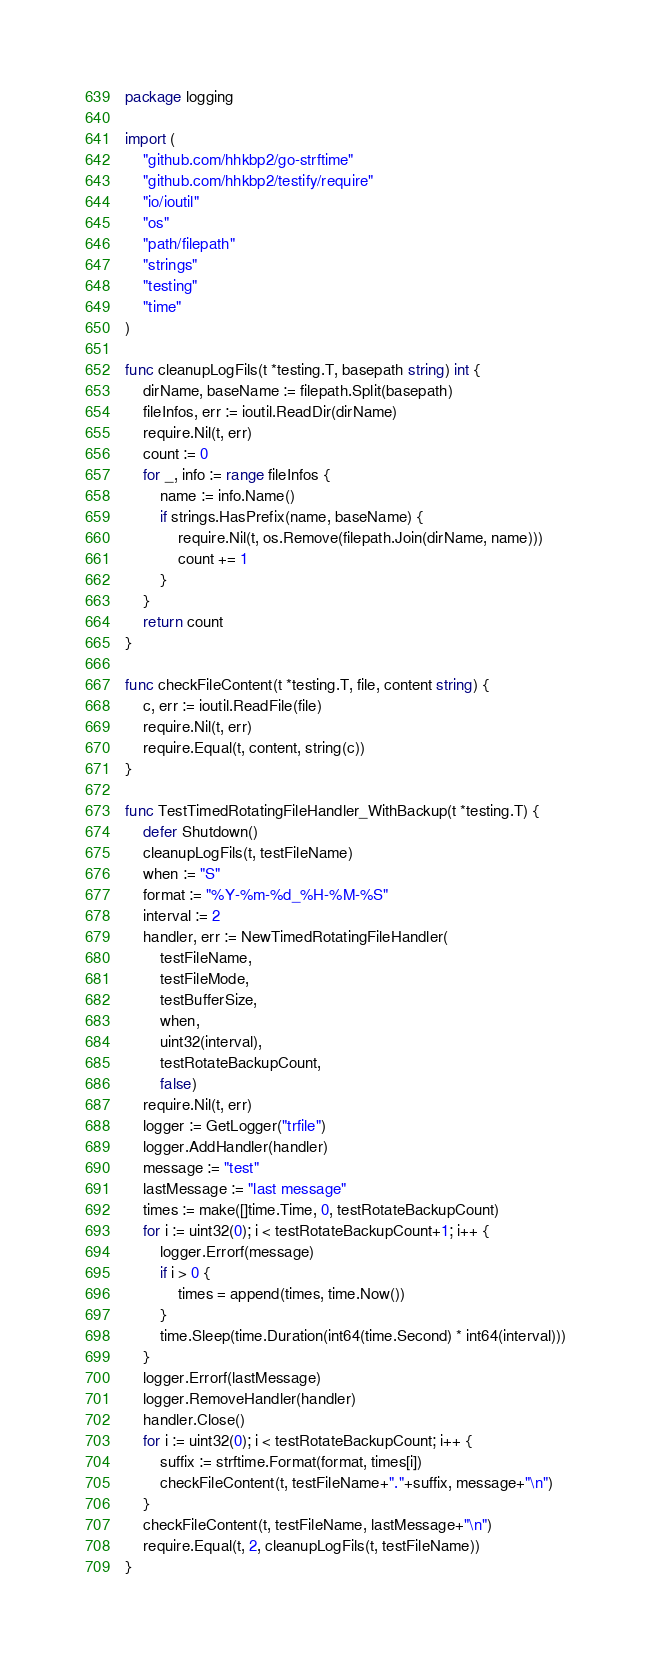<code> <loc_0><loc_0><loc_500><loc_500><_Go_>package logging

import (
	"github.com/hhkbp2/go-strftime"
	"github.com/hhkbp2/testify/require"
	"io/ioutil"
	"os"
	"path/filepath"
	"strings"
	"testing"
	"time"
)

func cleanupLogFils(t *testing.T, basepath string) int {
	dirName, baseName := filepath.Split(basepath)
	fileInfos, err := ioutil.ReadDir(dirName)
	require.Nil(t, err)
	count := 0
	for _, info := range fileInfos {
		name := info.Name()
		if strings.HasPrefix(name, baseName) {
			require.Nil(t, os.Remove(filepath.Join(dirName, name)))
			count += 1
		}
	}
	return count
}

func checkFileContent(t *testing.T, file, content string) {
	c, err := ioutil.ReadFile(file)
	require.Nil(t, err)
	require.Equal(t, content, string(c))
}

func TestTimedRotatingFileHandler_WithBackup(t *testing.T) {
	defer Shutdown()
	cleanupLogFils(t, testFileName)
	when := "S"
	format := "%Y-%m-%d_%H-%M-%S"
	interval := 2
	handler, err := NewTimedRotatingFileHandler(
		testFileName,
		testFileMode,
		testBufferSize,
		when,
		uint32(interval),
		testRotateBackupCount,
		false)
	require.Nil(t, err)
	logger := GetLogger("trfile")
	logger.AddHandler(handler)
	message := "test"
	lastMessage := "last message"
	times := make([]time.Time, 0, testRotateBackupCount)
	for i := uint32(0); i < testRotateBackupCount+1; i++ {
		logger.Errorf(message)
		if i > 0 {
			times = append(times, time.Now())
		}
		time.Sleep(time.Duration(int64(time.Second) * int64(interval)))
	}
	logger.Errorf(lastMessage)
	logger.RemoveHandler(handler)
	handler.Close()
	for i := uint32(0); i < testRotateBackupCount; i++ {
		suffix := strftime.Format(format, times[i])
		checkFileContent(t, testFileName+"."+suffix, message+"\n")
	}
	checkFileContent(t, testFileName, lastMessage+"\n")
	require.Equal(t, 2, cleanupLogFils(t, testFileName))
}
</code> 